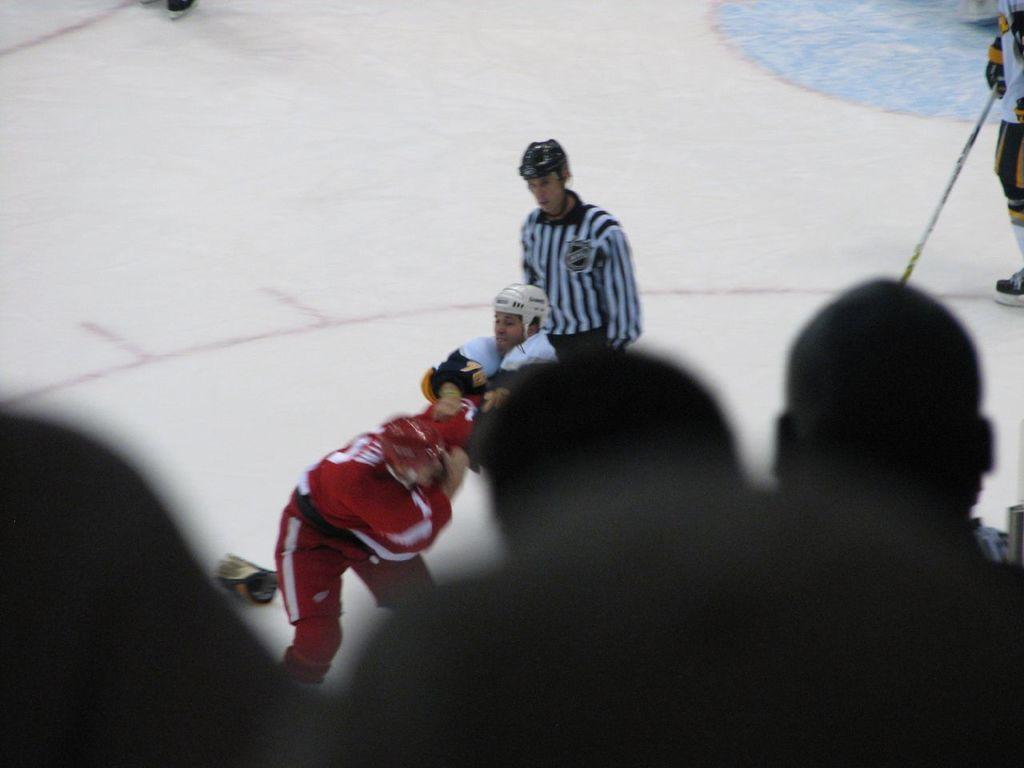Describe this image in one or two sentences. In front of the image we can see the heads of a people. In front of them there are people standing. On the left side of the image there is some object on the floor. On the right side of the image there is a person holding the stick. 